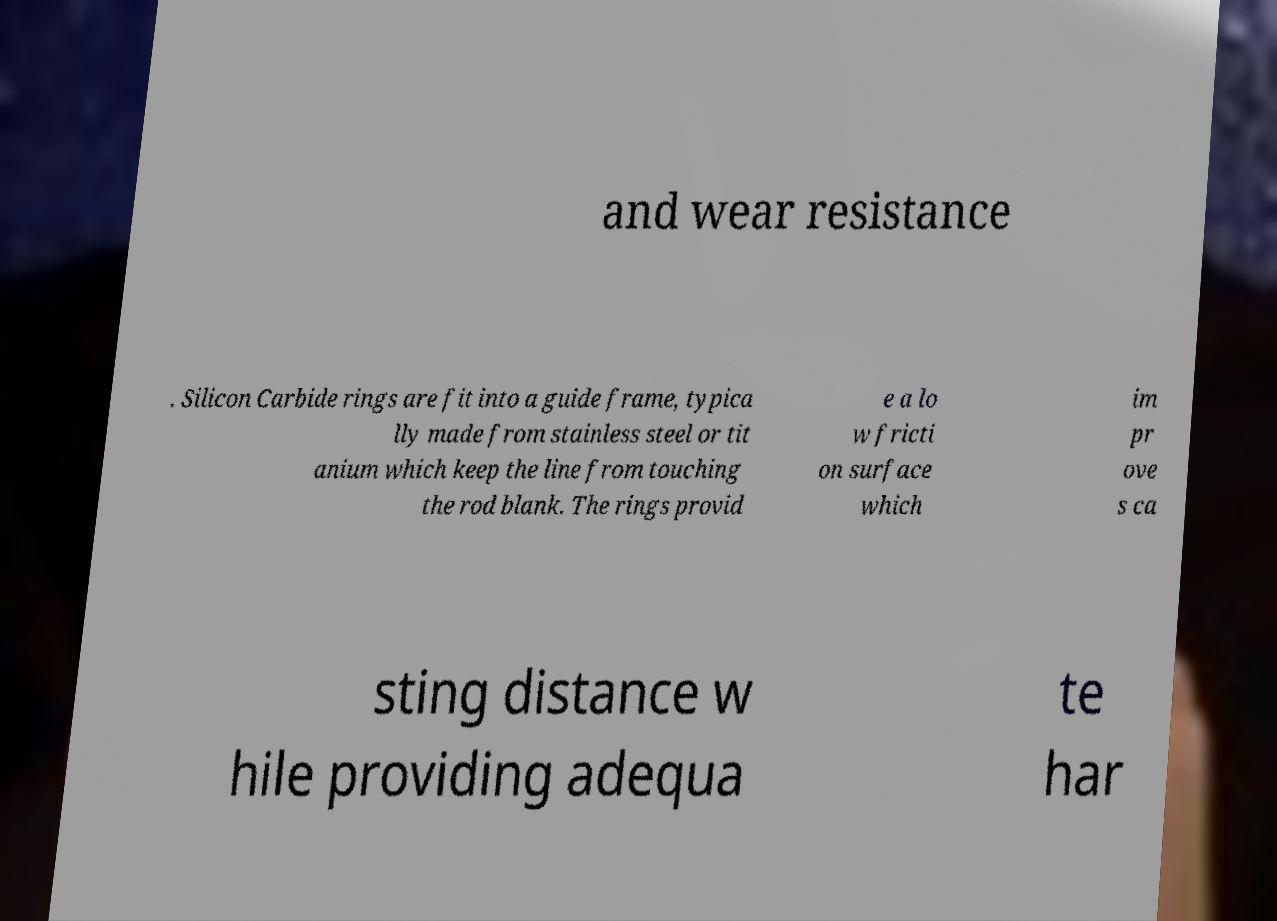There's text embedded in this image that I need extracted. Can you transcribe it verbatim? and wear resistance . Silicon Carbide rings are fit into a guide frame, typica lly made from stainless steel or tit anium which keep the line from touching the rod blank. The rings provid e a lo w fricti on surface which im pr ove s ca sting distance w hile providing adequa te har 